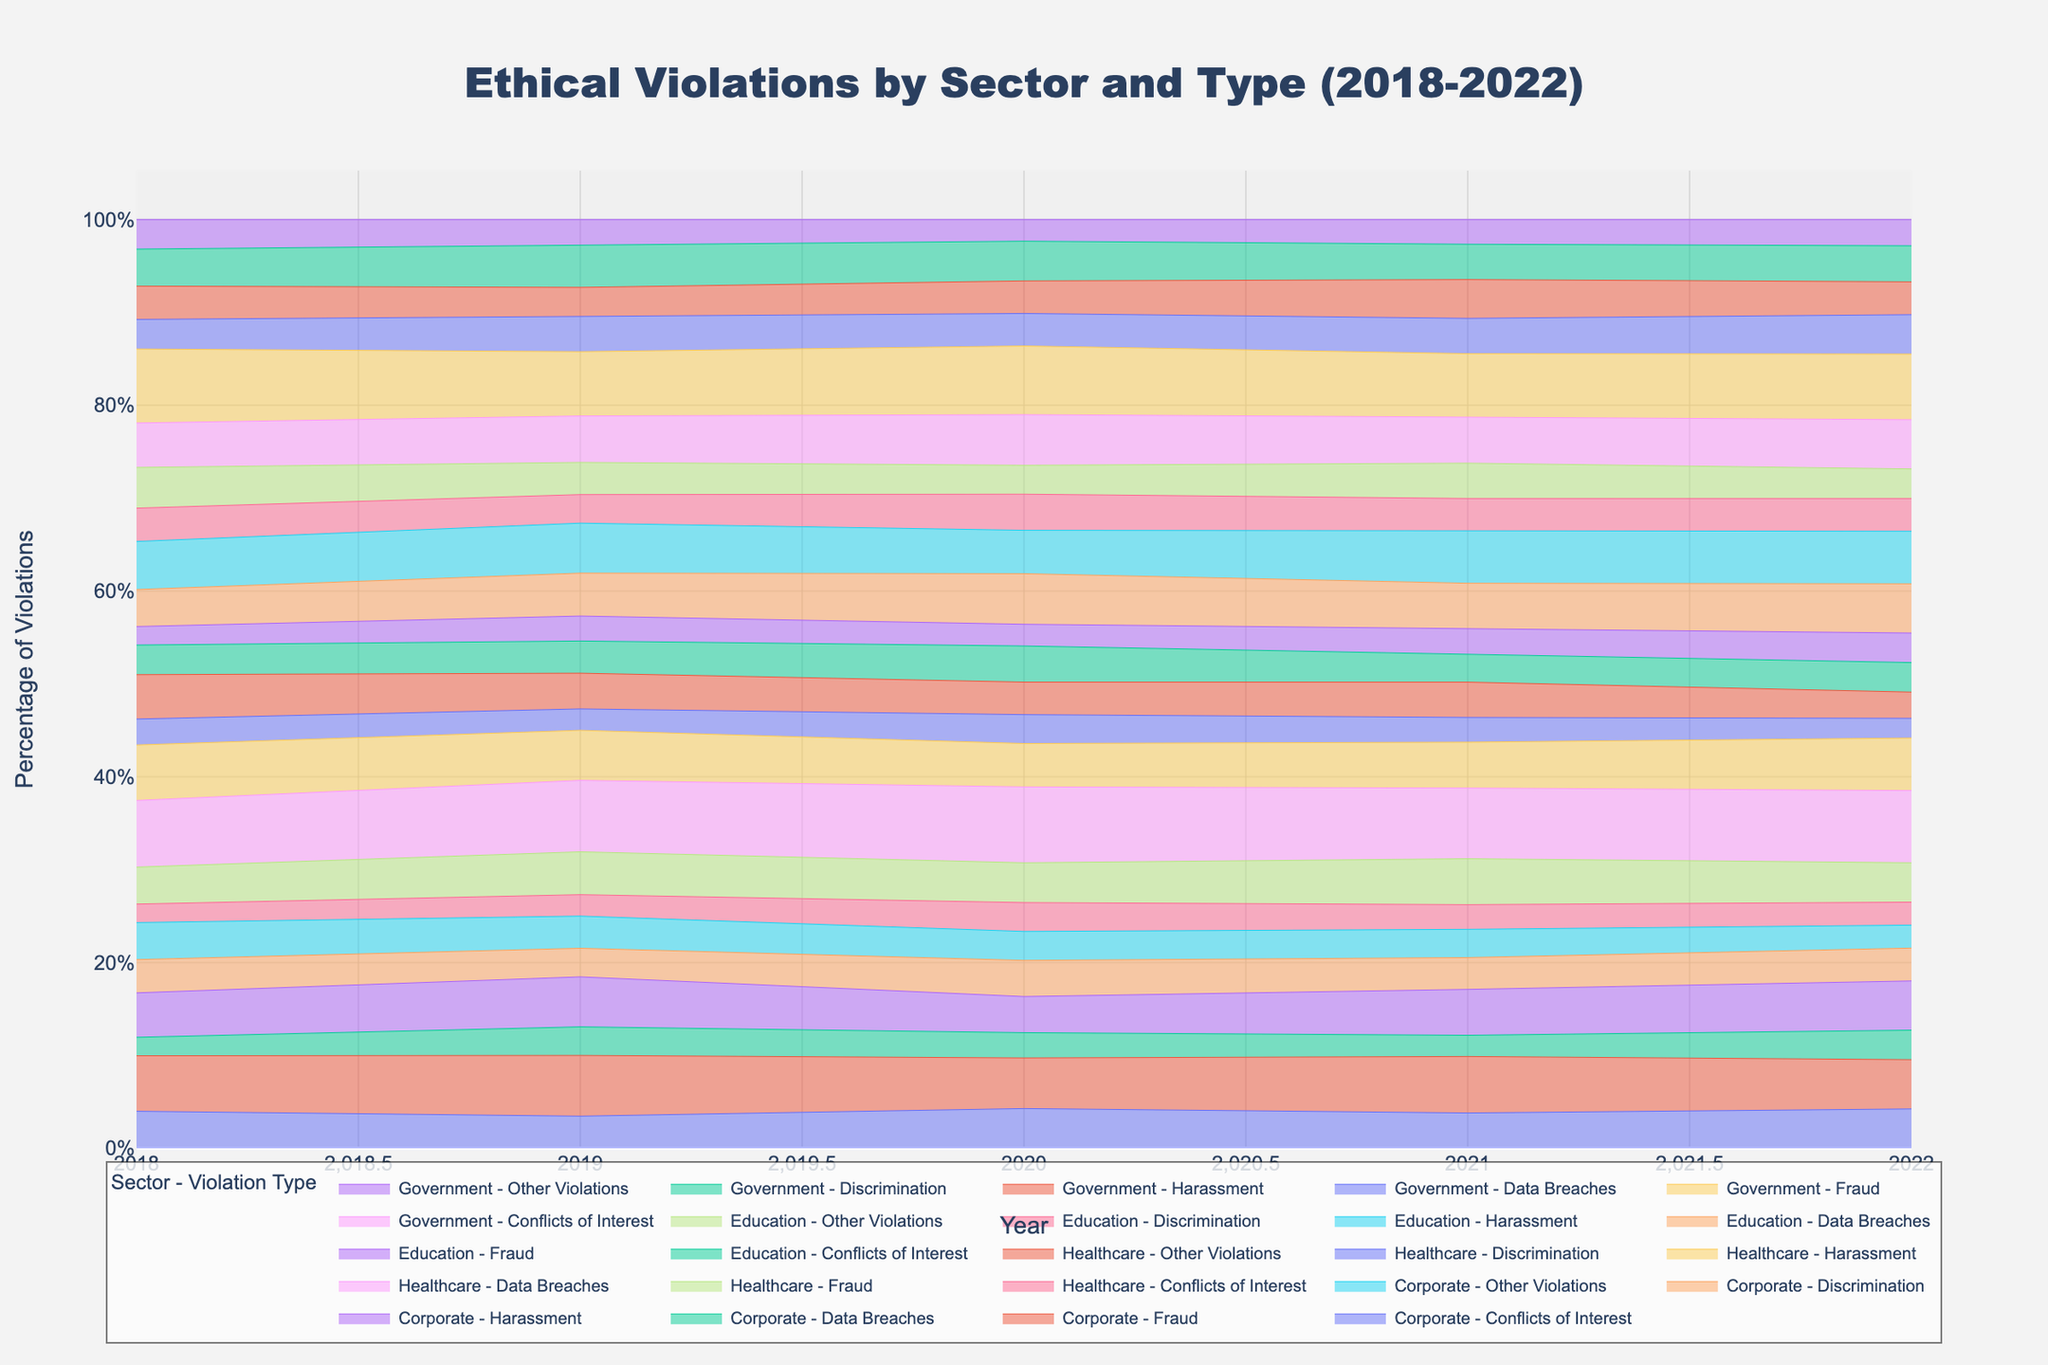What's the title of the figure? The title is at the top of the figure and is usually displayed prominently. Here, it reads "Ethical Violations by Sector and Type (2018-2022)."
Answer: Ethical Violations by Sector and Type (2018-2022) How many sectors are represented in the figure? The figure categorizes violations by sector, and each sector's name appears in the legend or along different colored areas in the chart. There are four sectors: Corporate, Healthcare, Education, and Government.
Answer: Four Which type of ethical violation is most prominent in the Healthcare sector in 2022? To find the most prominent violation type for Healthcare in 2022, locate the Healthcare category for the year 2022 and identify which area takes the largest space. For Healthcare in 2022, Data Breaches have the highest percentage.
Answer: Data Breaches In which year did the Corporate sector have the highest percentage of Harassment violations? To determine the year with the highest percentage of Harassment violations for the Corporate sector, observe the relative height of Harassment areas (likely in a darker shade) across the years for the Corporate category. Harassment is highest in 2022.
Answer: 2022 Compare the percentage of Discrimination violations in the Education sector between 2018 and 2022. Review the figure for the area covered by Discrimination (likely in a distinct color) in the Education sector for both 2018 and 2022. In 2018 and 2022, Discrimination percentages are similar but appear slightly higher in 2022.
Answer: Slightly higher in 2022 What is the trend in Fraud violations in the Government sector from 2018 to 2022? Look over the chart where Government Fraud is represented from 2018 through 2022. Frauds (likely in its specific color) seem to maintain consistently high levels across these years with a slight peak in 2020 and 2022.
Answer: Generally high with peak in 2020 and 2022 Which sector had the highest overall percentage of ethical violations in 2020? Summarize the largest combined areas for each sector in 2020, represented as a percentage of the chart. The Government sector appears to have the most extensive coverage in 2020.
Answer: Government Are Data Breaches more prevalent in the Healthcare sector compared to the Corporate sector over the years? Examine and compare the relative areas covered by Data Breaches (specific colors) in both the Healthcare and Corporate sectors from 2018 to 2022. Data Breaches consistently cover a larger area in Healthcare than in Corporate.
Answer: Yes Has there been an increasing or decreasing trend in Other Violations for the Corporate sector? To understand the trend, follow the color representing Other Violations from 2018 to 2022 for the Corporate sector. Other Violations show a decreasing trend over these years.
Answer: Decreasing 